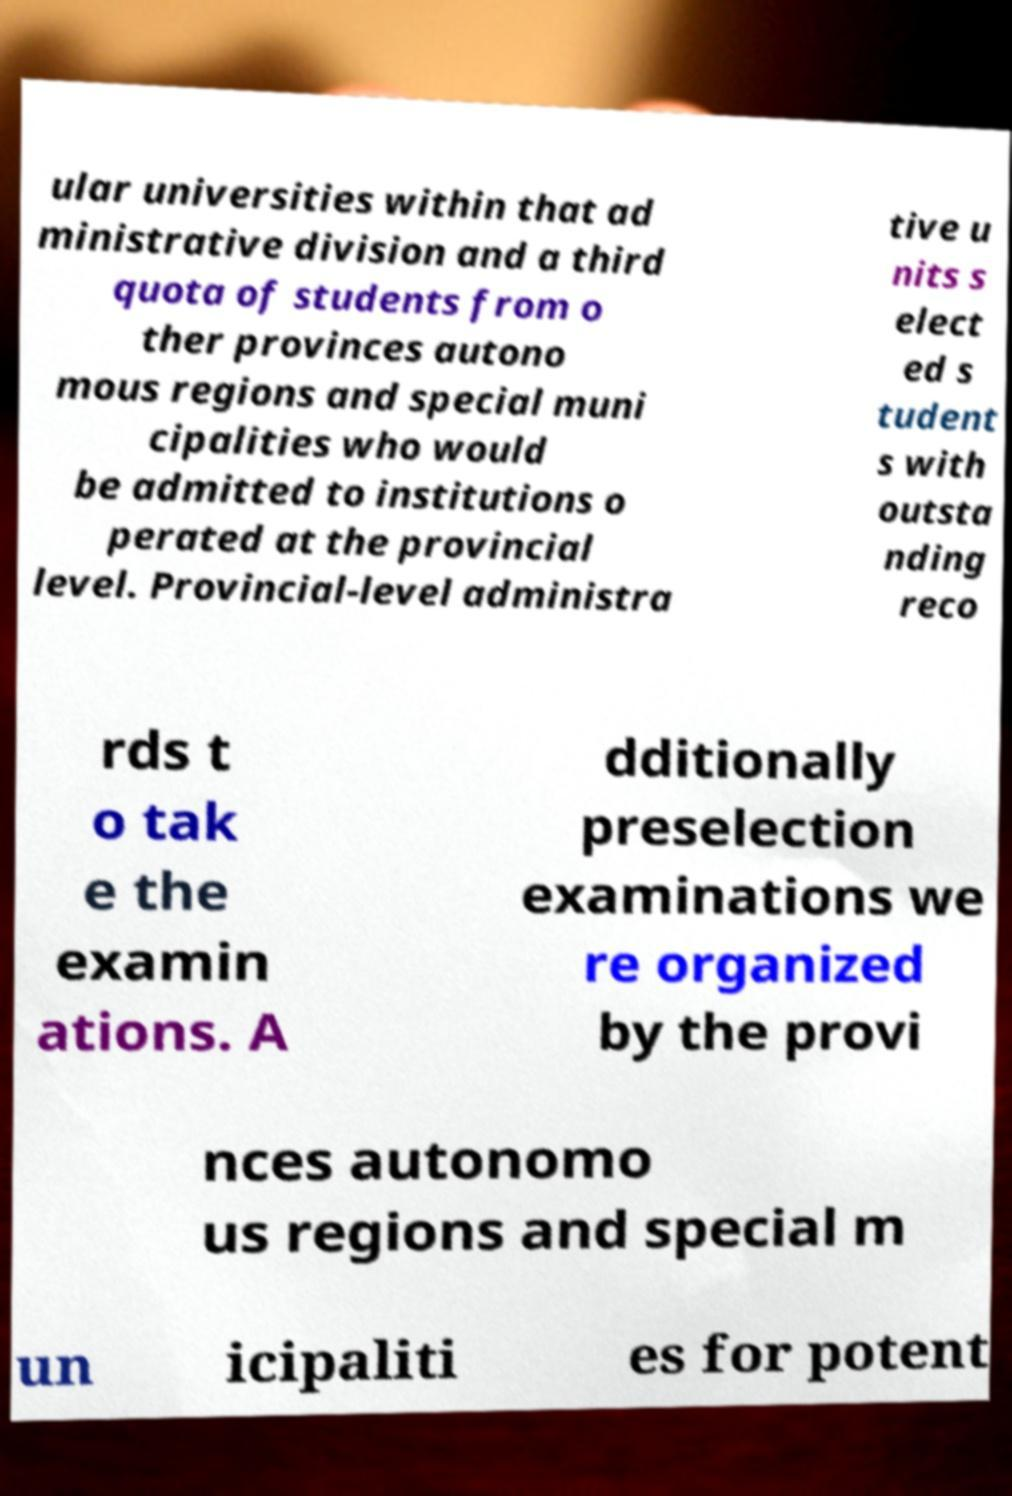Can you accurately transcribe the text from the provided image for me? ular universities within that ad ministrative division and a third quota of students from o ther provinces autono mous regions and special muni cipalities who would be admitted to institutions o perated at the provincial level. Provincial-level administra tive u nits s elect ed s tudent s with outsta nding reco rds t o tak e the examin ations. A dditionally preselection examinations we re organized by the provi nces autonomo us regions and special m un icipaliti es for potent 